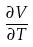Convert formula to latex. <formula><loc_0><loc_0><loc_500><loc_500>\frac { \partial V } { \partial T }</formula> 